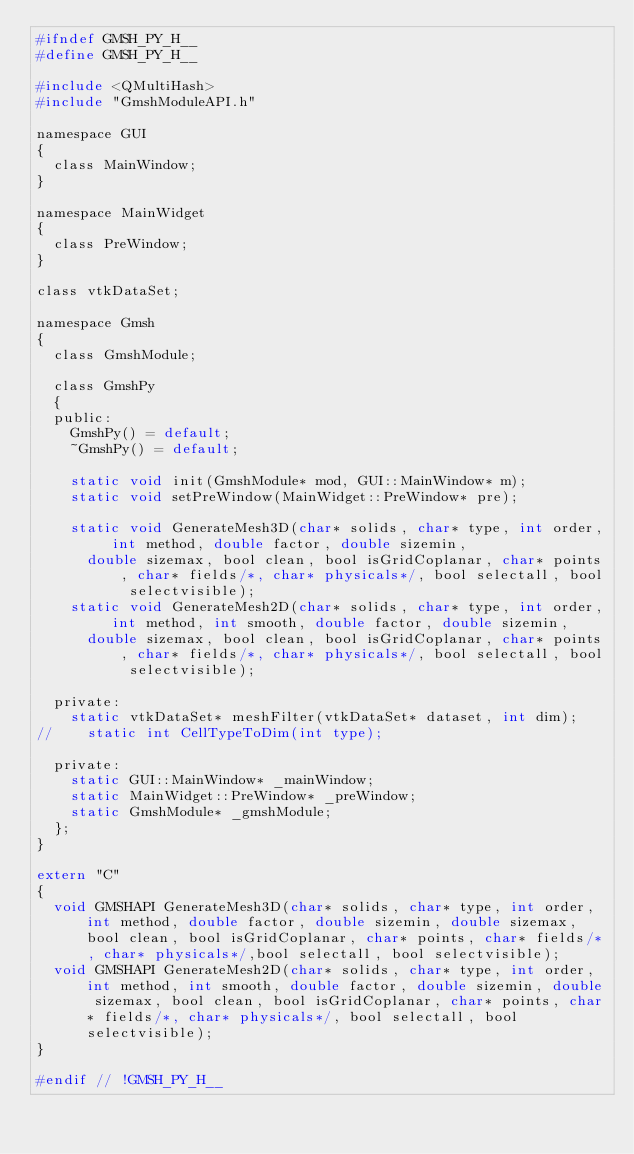<code> <loc_0><loc_0><loc_500><loc_500><_C_>#ifndef GMSH_PY_H__
#define GMSH_PY_H__

#include <QMultiHash>
#include "GmshModuleAPI.h"

namespace GUI
{
	class MainWindow;
}

namespace MainWidget
{
	class PreWindow;
}

class vtkDataSet;

namespace Gmsh
{
	class GmshModule;

	class GmshPy
	{
	public:
		GmshPy() = default;
		~GmshPy() = default;

		static void init(GmshModule* mod, GUI::MainWindow* m);
		static void setPreWindow(MainWidget::PreWindow* pre);
	 
		static void GenerateMesh3D(char* solids, char* type, int order, int method, double factor, double sizemin, 
			double sizemax, bool clean, bool isGridCoplanar, char* points, char* fields/*, char* physicals*/, bool selectall, bool selectvisible);
		static void GenerateMesh2D(char* solids, char* type, int order, int method, int smooth,	double factor, double sizemin, 
			double sizemax, bool clean, bool isGridCoplanar, char* points, char* fields/*, char* physicals*/, bool selectall, bool selectvisible);

	private:
		static vtkDataSet* meshFilter(vtkDataSet* dataset, int dim);
//		static int CellTypeToDim(int type);

	private:
		static GUI::MainWindow* _mainWindow;
		static MainWidget::PreWindow* _preWindow;
		static GmshModule* _gmshModule;
	};
}

extern "C"
{
	void GMSHAPI GenerateMesh3D(char* solids, char* type, int order, int method, double factor, double sizemin, double sizemax, bool clean, bool isGridCoplanar, char* points, char* fields/*, char* physicals*/,bool selectall, bool selectvisible);
	void GMSHAPI GenerateMesh2D(char* solids, char* type, int order, int method, int smooth, double factor, double sizemin, double sizemax, bool clean, bool isGridCoplanar, char* points, char* fields/*, char* physicals*/, bool selectall, bool selectvisible);
}

#endif // !GMSH_PY_H__
</code> 